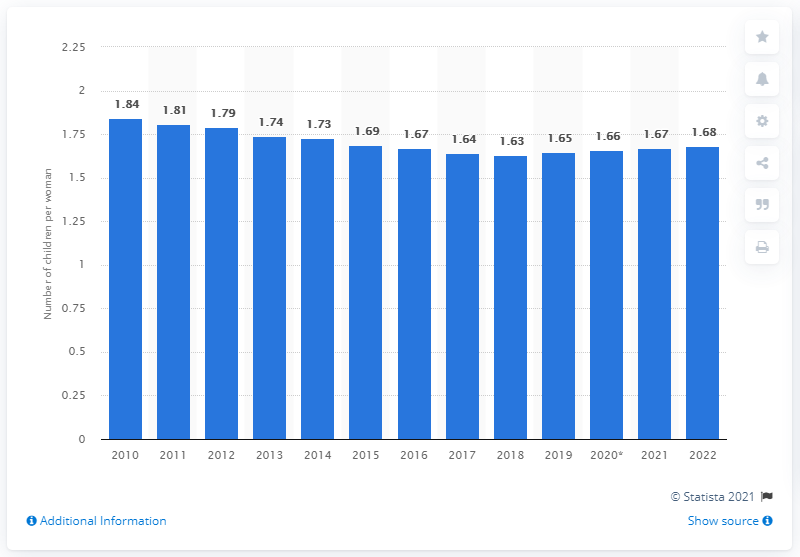Mention a couple of crucial points in this snapshot. In 2010, the birth rate in Belgium was 1.84. 